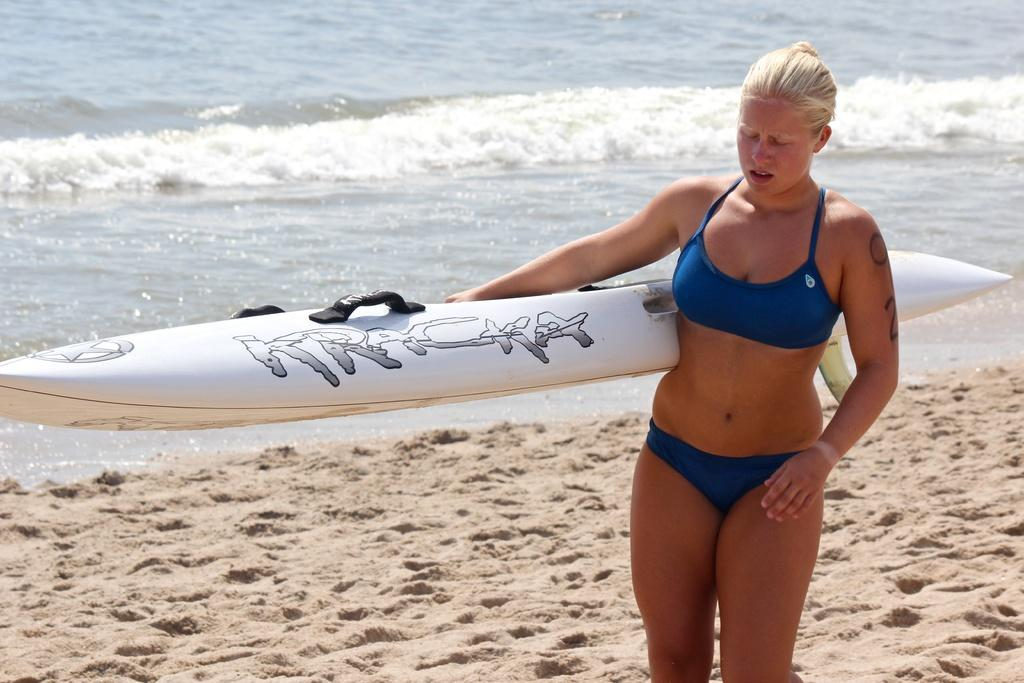Who is present in the image? There is a woman in the image. What is the woman holding in the image? The woman is holding a surfboard. What type of terrain is the woman walking on? The woman is walking on sand. What can be seen in the distance behind the woman? There is a sea visible in the background of the image. What is a characteristic of the sea in the image? There is water in the sea. How many stars can be seen on the woman's shirt in the image? There is no information about the woman's shirt or any stars in the image. 